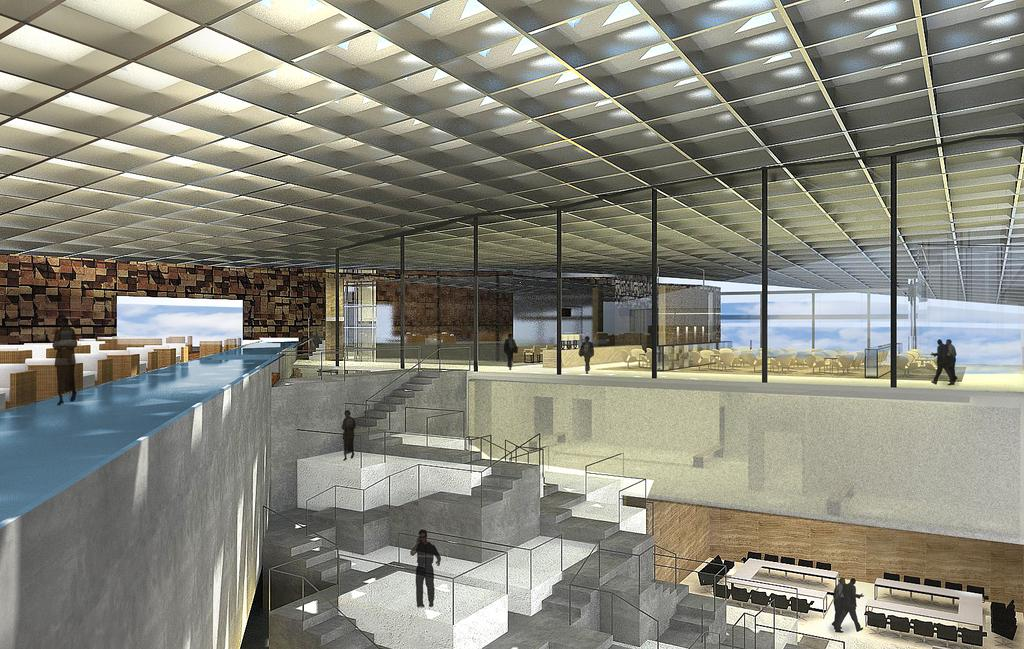What type of image is being described? The image is an animated picture. What architectural feature can be seen in the image? There are steps in the image. What type of furniture is present in the image? There are tables and chairs in the image. Who or what is present in the image? There are people in the image. What type of ground feature is visible in the image? There is a path in the image. What part of a building can be seen in the image? There is a ceiling in the image. How many cats are sitting on the tables in the image? There are no cats present in the image; it features people, steps, tables and chairs, a path, and a ceiling. 